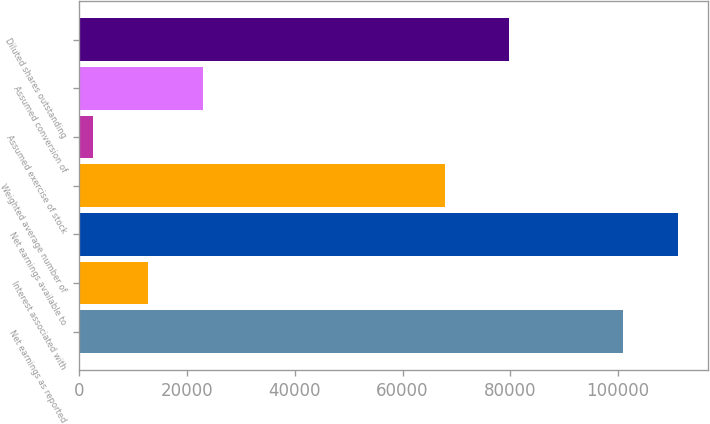<chart> <loc_0><loc_0><loc_500><loc_500><bar_chart><fcel>Net earnings as reported<fcel>Interest associated with<fcel>Net earnings available to<fcel>Weighted average number of<fcel>Assumed exercise of stock<fcel>Assumed conversion of<fcel>Diluted shares outstanding<nl><fcel>100896<fcel>12750.3<fcel>111176<fcel>67845<fcel>2470<fcel>23030.6<fcel>79778<nl></chart> 